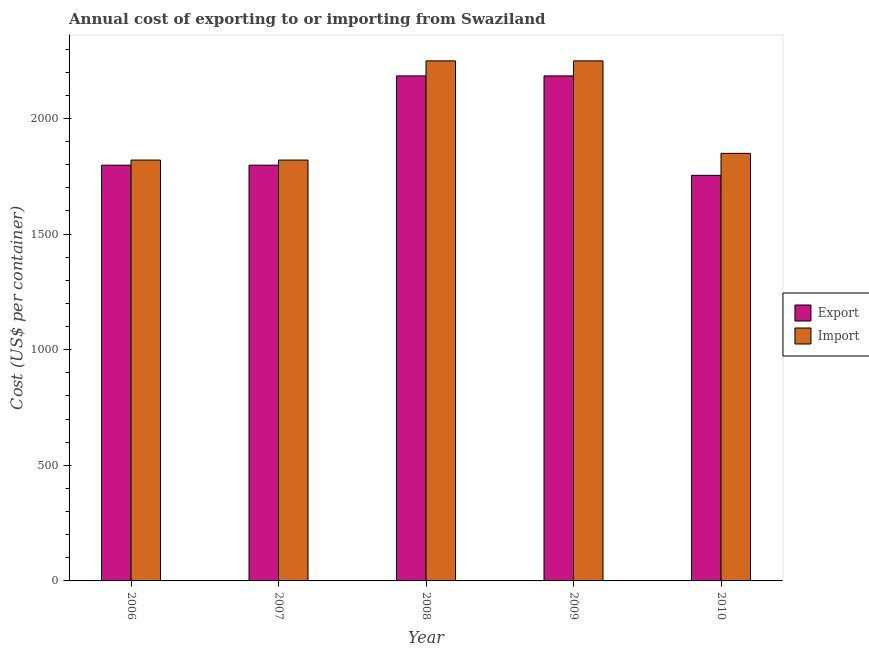Are the number of bars on each tick of the X-axis equal?
Make the answer very short. Yes. In how many cases, is the number of bars for a given year not equal to the number of legend labels?
Keep it short and to the point. 0. What is the export cost in 2010?
Make the answer very short. 1754. Across all years, what is the maximum export cost?
Provide a short and direct response. 2184. Across all years, what is the minimum import cost?
Provide a succinct answer. 1820. What is the total export cost in the graph?
Provide a short and direct response. 9718. What is the difference between the import cost in 2007 and that in 2010?
Your answer should be very brief. -29. What is the average export cost per year?
Your answer should be very brief. 1943.6. In how many years, is the import cost greater than 1300 US$?
Your answer should be compact. 5. What is the ratio of the export cost in 2006 to that in 2008?
Offer a terse response. 0.82. Is the export cost in 2009 less than that in 2010?
Your response must be concise. No. Is the difference between the import cost in 2008 and 2009 greater than the difference between the export cost in 2008 and 2009?
Offer a very short reply. No. What is the difference between the highest and the second highest import cost?
Offer a very short reply. 0. What is the difference between the highest and the lowest export cost?
Your answer should be compact. 430. Is the sum of the export cost in 2007 and 2010 greater than the maximum import cost across all years?
Offer a very short reply. Yes. What does the 1st bar from the left in 2006 represents?
Your response must be concise. Export. What does the 2nd bar from the right in 2007 represents?
Provide a succinct answer. Export. How many bars are there?
Your answer should be compact. 10. What is the difference between two consecutive major ticks on the Y-axis?
Your response must be concise. 500. Does the graph contain any zero values?
Offer a terse response. No. How are the legend labels stacked?
Ensure brevity in your answer.  Vertical. What is the title of the graph?
Give a very brief answer. Annual cost of exporting to or importing from Swaziland. What is the label or title of the X-axis?
Give a very brief answer. Year. What is the label or title of the Y-axis?
Your response must be concise. Cost (US$ per container). What is the Cost (US$ per container) of Export in 2006?
Your answer should be very brief. 1798. What is the Cost (US$ per container) of Import in 2006?
Keep it short and to the point. 1820. What is the Cost (US$ per container) in Export in 2007?
Offer a terse response. 1798. What is the Cost (US$ per container) of Import in 2007?
Your response must be concise. 1820. What is the Cost (US$ per container) of Export in 2008?
Your answer should be very brief. 2184. What is the Cost (US$ per container) in Import in 2008?
Make the answer very short. 2249. What is the Cost (US$ per container) of Export in 2009?
Offer a very short reply. 2184. What is the Cost (US$ per container) of Import in 2009?
Your answer should be very brief. 2249. What is the Cost (US$ per container) of Export in 2010?
Offer a terse response. 1754. What is the Cost (US$ per container) of Import in 2010?
Provide a succinct answer. 1849. Across all years, what is the maximum Cost (US$ per container) in Export?
Make the answer very short. 2184. Across all years, what is the maximum Cost (US$ per container) in Import?
Ensure brevity in your answer.  2249. Across all years, what is the minimum Cost (US$ per container) in Export?
Ensure brevity in your answer.  1754. Across all years, what is the minimum Cost (US$ per container) in Import?
Your response must be concise. 1820. What is the total Cost (US$ per container) of Export in the graph?
Your response must be concise. 9718. What is the total Cost (US$ per container) of Import in the graph?
Provide a short and direct response. 9987. What is the difference between the Cost (US$ per container) of Import in 2006 and that in 2007?
Your answer should be compact. 0. What is the difference between the Cost (US$ per container) in Export in 2006 and that in 2008?
Your answer should be compact. -386. What is the difference between the Cost (US$ per container) of Import in 2006 and that in 2008?
Your answer should be very brief. -429. What is the difference between the Cost (US$ per container) of Export in 2006 and that in 2009?
Offer a very short reply. -386. What is the difference between the Cost (US$ per container) in Import in 2006 and that in 2009?
Offer a terse response. -429. What is the difference between the Cost (US$ per container) of Export in 2007 and that in 2008?
Offer a terse response. -386. What is the difference between the Cost (US$ per container) in Import in 2007 and that in 2008?
Offer a terse response. -429. What is the difference between the Cost (US$ per container) of Export in 2007 and that in 2009?
Make the answer very short. -386. What is the difference between the Cost (US$ per container) of Import in 2007 and that in 2009?
Make the answer very short. -429. What is the difference between the Cost (US$ per container) of Export in 2007 and that in 2010?
Provide a short and direct response. 44. What is the difference between the Cost (US$ per container) in Import in 2007 and that in 2010?
Make the answer very short. -29. What is the difference between the Cost (US$ per container) of Export in 2008 and that in 2009?
Provide a succinct answer. 0. What is the difference between the Cost (US$ per container) in Import in 2008 and that in 2009?
Offer a very short reply. 0. What is the difference between the Cost (US$ per container) in Export in 2008 and that in 2010?
Keep it short and to the point. 430. What is the difference between the Cost (US$ per container) in Import in 2008 and that in 2010?
Your response must be concise. 400. What is the difference between the Cost (US$ per container) in Export in 2009 and that in 2010?
Offer a terse response. 430. What is the difference between the Cost (US$ per container) in Import in 2009 and that in 2010?
Your answer should be compact. 400. What is the difference between the Cost (US$ per container) of Export in 2006 and the Cost (US$ per container) of Import in 2007?
Give a very brief answer. -22. What is the difference between the Cost (US$ per container) in Export in 2006 and the Cost (US$ per container) in Import in 2008?
Provide a short and direct response. -451. What is the difference between the Cost (US$ per container) in Export in 2006 and the Cost (US$ per container) in Import in 2009?
Provide a succinct answer. -451. What is the difference between the Cost (US$ per container) of Export in 2006 and the Cost (US$ per container) of Import in 2010?
Your answer should be compact. -51. What is the difference between the Cost (US$ per container) of Export in 2007 and the Cost (US$ per container) of Import in 2008?
Your answer should be compact. -451. What is the difference between the Cost (US$ per container) in Export in 2007 and the Cost (US$ per container) in Import in 2009?
Provide a succinct answer. -451. What is the difference between the Cost (US$ per container) in Export in 2007 and the Cost (US$ per container) in Import in 2010?
Provide a succinct answer. -51. What is the difference between the Cost (US$ per container) in Export in 2008 and the Cost (US$ per container) in Import in 2009?
Offer a very short reply. -65. What is the difference between the Cost (US$ per container) of Export in 2008 and the Cost (US$ per container) of Import in 2010?
Ensure brevity in your answer.  335. What is the difference between the Cost (US$ per container) in Export in 2009 and the Cost (US$ per container) in Import in 2010?
Your answer should be compact. 335. What is the average Cost (US$ per container) of Export per year?
Your answer should be compact. 1943.6. What is the average Cost (US$ per container) in Import per year?
Give a very brief answer. 1997.4. In the year 2008, what is the difference between the Cost (US$ per container) in Export and Cost (US$ per container) in Import?
Your answer should be compact. -65. In the year 2009, what is the difference between the Cost (US$ per container) of Export and Cost (US$ per container) of Import?
Offer a terse response. -65. In the year 2010, what is the difference between the Cost (US$ per container) of Export and Cost (US$ per container) of Import?
Provide a succinct answer. -95. What is the ratio of the Cost (US$ per container) in Export in 2006 to that in 2007?
Offer a very short reply. 1. What is the ratio of the Cost (US$ per container) of Export in 2006 to that in 2008?
Offer a very short reply. 0.82. What is the ratio of the Cost (US$ per container) in Import in 2006 to that in 2008?
Your answer should be very brief. 0.81. What is the ratio of the Cost (US$ per container) in Export in 2006 to that in 2009?
Provide a succinct answer. 0.82. What is the ratio of the Cost (US$ per container) of Import in 2006 to that in 2009?
Your answer should be very brief. 0.81. What is the ratio of the Cost (US$ per container) of Export in 2006 to that in 2010?
Make the answer very short. 1.03. What is the ratio of the Cost (US$ per container) in Import in 2006 to that in 2010?
Ensure brevity in your answer.  0.98. What is the ratio of the Cost (US$ per container) of Export in 2007 to that in 2008?
Give a very brief answer. 0.82. What is the ratio of the Cost (US$ per container) of Import in 2007 to that in 2008?
Keep it short and to the point. 0.81. What is the ratio of the Cost (US$ per container) in Export in 2007 to that in 2009?
Your response must be concise. 0.82. What is the ratio of the Cost (US$ per container) in Import in 2007 to that in 2009?
Give a very brief answer. 0.81. What is the ratio of the Cost (US$ per container) in Export in 2007 to that in 2010?
Give a very brief answer. 1.03. What is the ratio of the Cost (US$ per container) of Import in 2007 to that in 2010?
Provide a short and direct response. 0.98. What is the ratio of the Cost (US$ per container) in Export in 2008 to that in 2010?
Your response must be concise. 1.25. What is the ratio of the Cost (US$ per container) of Import in 2008 to that in 2010?
Offer a very short reply. 1.22. What is the ratio of the Cost (US$ per container) in Export in 2009 to that in 2010?
Give a very brief answer. 1.25. What is the ratio of the Cost (US$ per container) in Import in 2009 to that in 2010?
Your answer should be very brief. 1.22. What is the difference between the highest and the lowest Cost (US$ per container) of Export?
Your response must be concise. 430. What is the difference between the highest and the lowest Cost (US$ per container) in Import?
Offer a terse response. 429. 